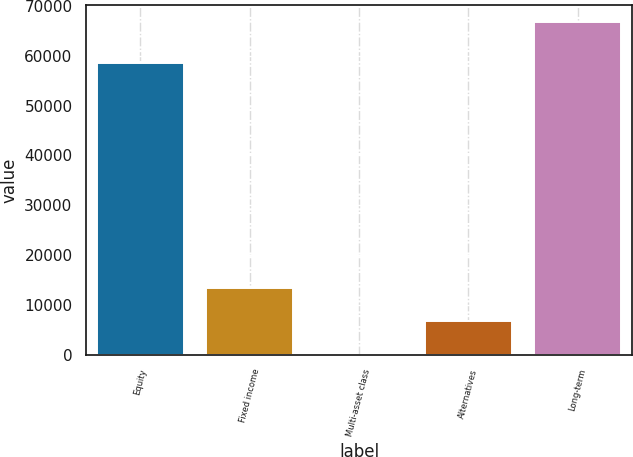<chart> <loc_0><loc_0><loc_500><loc_500><bar_chart><fcel>Equity<fcel>Fixed income<fcel>Multi-asset class<fcel>Alternatives<fcel>Long-term<nl><fcel>58507<fcel>13413<fcel>51<fcel>6732<fcel>66861<nl></chart> 